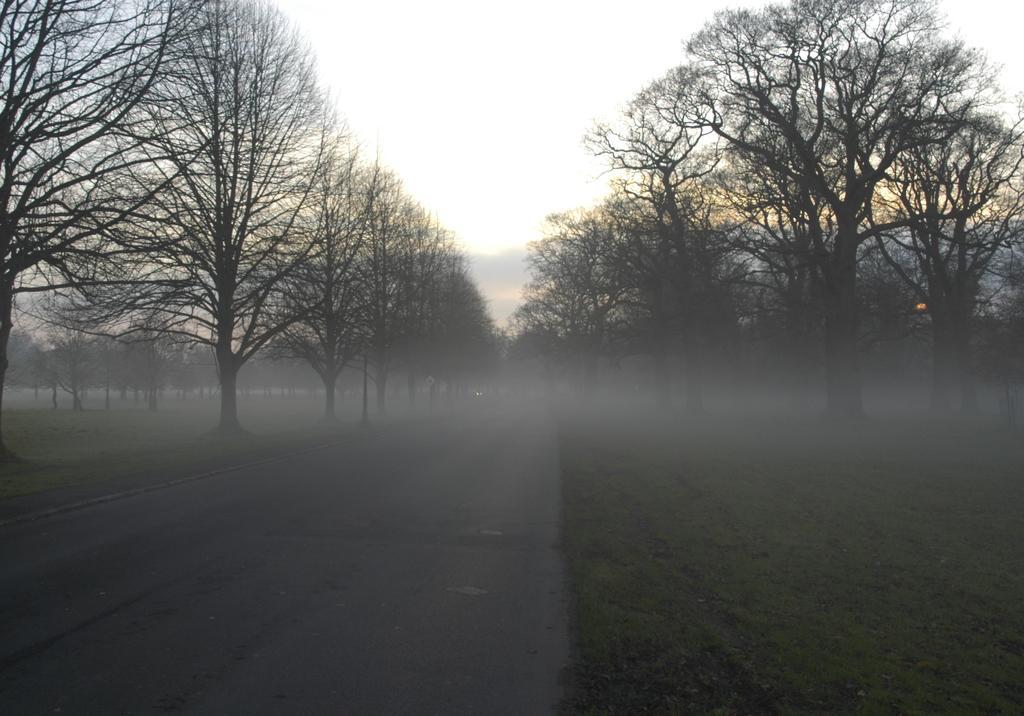How would you summarize this image in a sentence or two? In this picture we can see trees, and, snow and sky. 